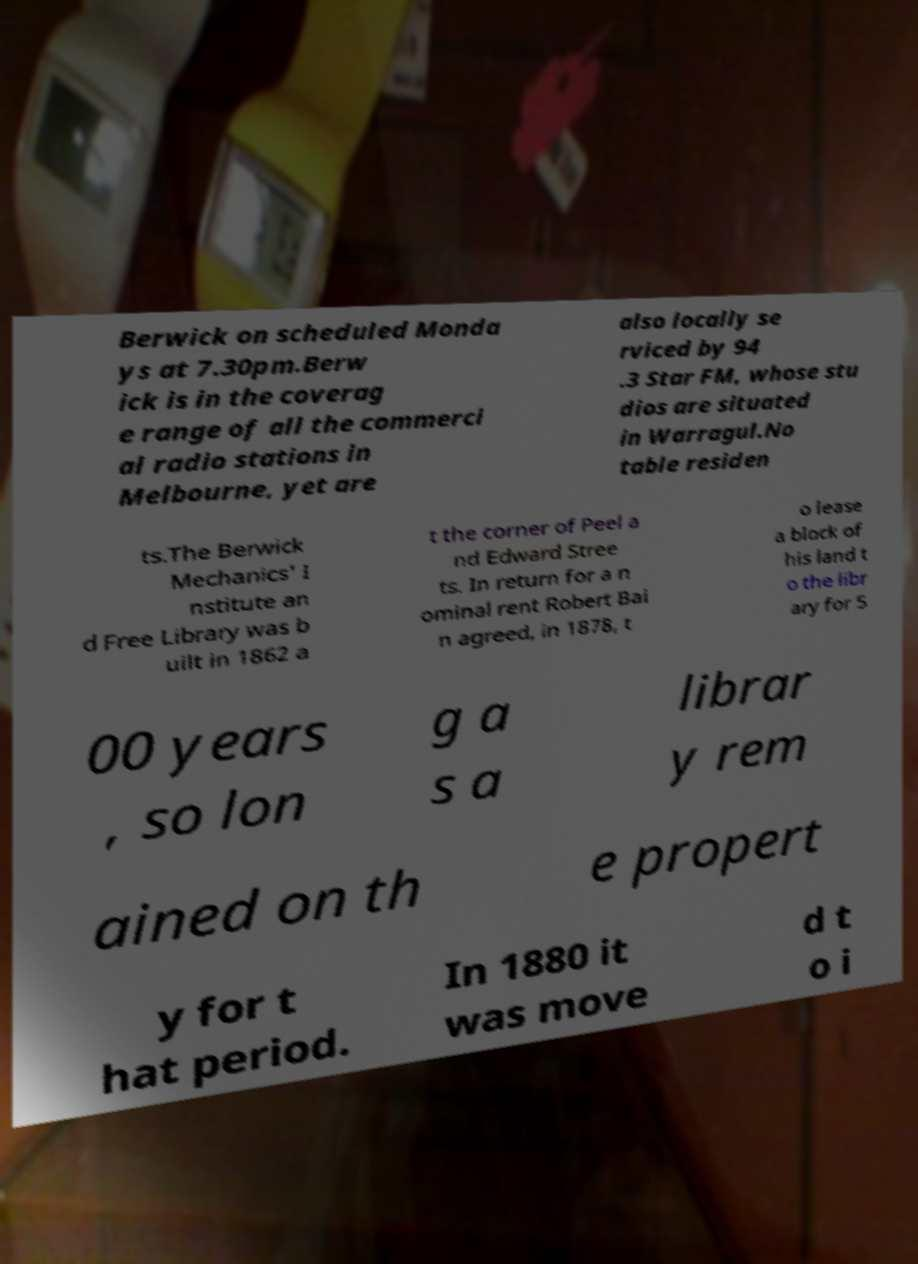I need the written content from this picture converted into text. Can you do that? Berwick on scheduled Monda ys at 7.30pm.Berw ick is in the coverag e range of all the commerci al radio stations in Melbourne, yet are also locally se rviced by 94 .3 Star FM, whose stu dios are situated in Warragul.No table residen ts.The Berwick Mechanics' I nstitute an d Free Library was b uilt in 1862 a t the corner of Peel a nd Edward Stree ts. In return for a n ominal rent Robert Bai n agreed, in 1878, t o lease a block of his land t o the libr ary for 5 00 years , so lon g a s a librar y rem ained on th e propert y for t hat period. In 1880 it was move d t o i 